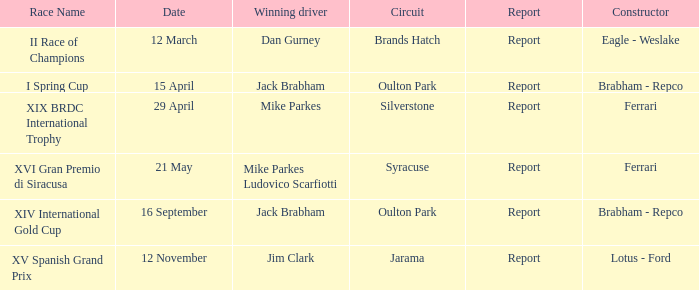What company constrcuted the vehicle with a circuit of oulton park on 15 april? Brabham - Repco. 